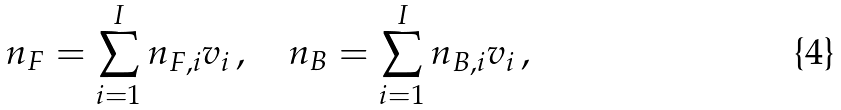Convert formula to latex. <formula><loc_0><loc_0><loc_500><loc_500>n _ { F } = \sum _ { i = 1 } ^ { I } n _ { F , i } v _ { i } \, , \quad n _ { B } = \sum _ { i = 1 } ^ { I } n _ { B , i } v _ { i } \, ,</formula> 